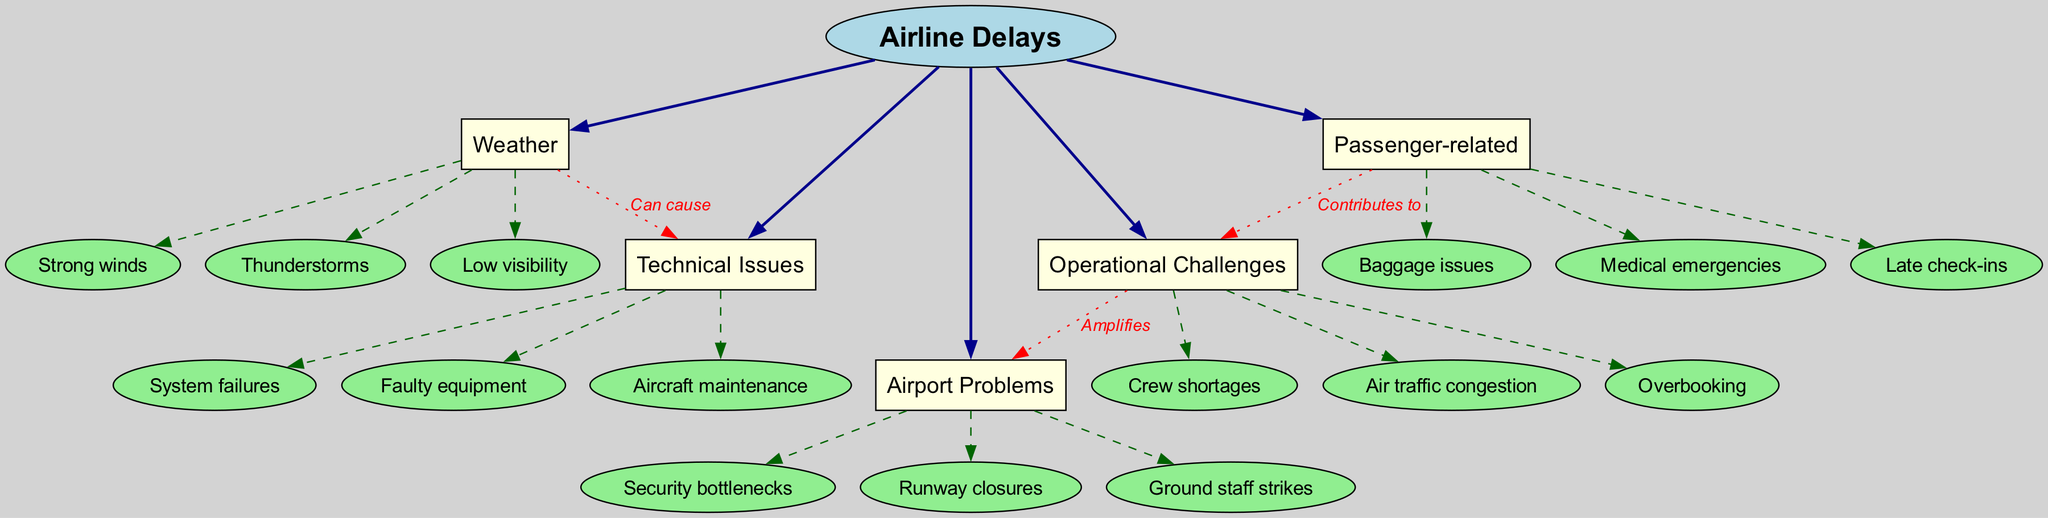What is the central theme of the diagram? The diagram's central theme, as indicated at the center node, is "Airline Delays." This node encapsulates the overall focus of the mind map, connecting all contributing factors to airline delays.
Answer: Airline Delays How many main branches are there in the diagram? The diagram features five main branches that stem from the center node: Weather, Technical Issues, Operational Challenges, Airport Problems, and Passenger-related. Counting these branches provides the answer.
Answer: Five Which main branch includes 'Strong winds'? The sub-branch 'Strong winds' is a part of the 'Weather' main branch. This connection can be identified by visually tracing the link from 'Weather' to its sub-branches.
Answer: Weather What label describes the relationship between 'Weather' and 'Technical Issues'? The connection between 'Weather' and 'Technical Issues' is labeled as "Can cause." This is outlined in the connections section of the diagram, converting this visual relationship into a textual explanation.
Answer: Can cause What contributes to 'Operational Challenges'? The 'Passenger-related' category is noted as a contributing factor to 'Operational Challenges' in the connections section. The diagram clearly indicates this relationship, guiding the answer.
Answer: Passenger-related How does 'Operational Challenges' affect 'Airport Problems'? The relationship is described with the label "Amplifies," indicating that issues arising from operational challenges worsen or increase airport problems. This explanation is found within the connections section of the diagram.
Answer: Amplifies Which specific sub-branch corresponds to 'Late check-ins'? 'Late check-ins' is a sub-branch under the 'Passenger-related' main branch. This can be verified by tracing the connection from 'Passenger-related' to its corresponding sub-branches listed.
Answer: Passenger-related What type of issues does 'Technical Issues' cover? The 'Technical Issues' main branch covers various problems such as 'Aircraft maintenance', 'System failures', and 'Faulty equipment', highlighting specific contributing factors to delays in aviation.
Answer: Aircraft maintenance, System failures, Faulty equipment What is the significance of 'Ground staff strikes' in the diagram? 'Ground staff strikes' is a sub-branch listed under the 'Airport Problems' main branch. This detail outlines a specific problem contributing to airline delays stemming from operational disruptions at the airport.
Answer: Airport Problems 